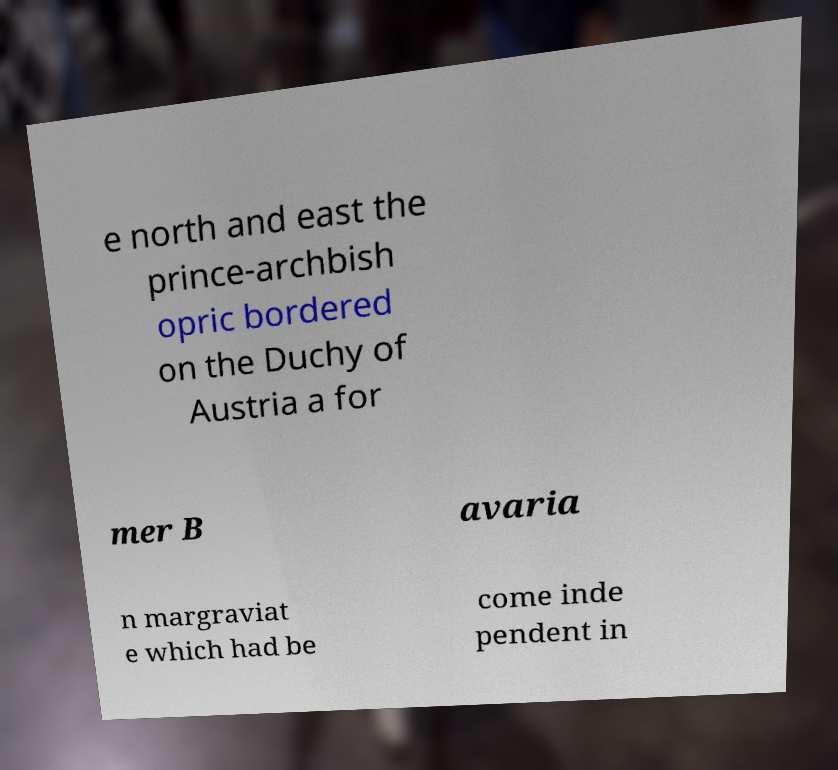Please read and relay the text visible in this image. What does it say? e north and east the prince-archbish opric bordered on the Duchy of Austria a for mer B avaria n margraviat e which had be come inde pendent in 